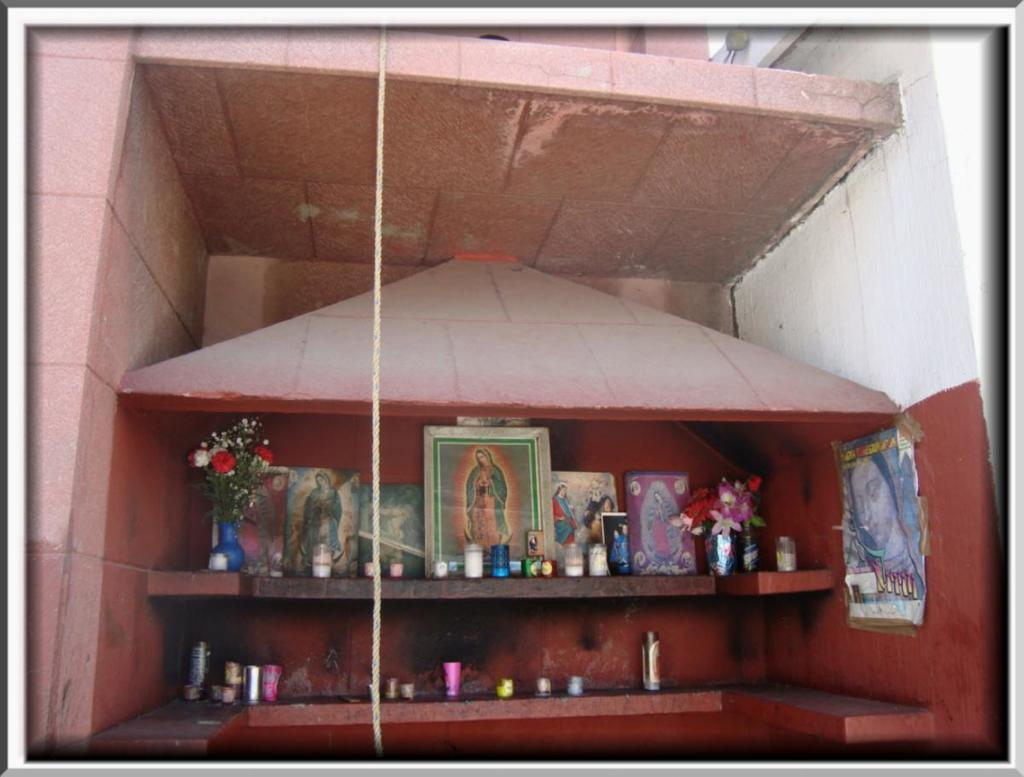What can be seen on the shelf in the image? There is a photo of Jesus and a flower vase on the shelf in the image. Can you describe the photo on the shelf? The photo on the shelf is of Jesus. What else is present on the shelf besides the photo? There is a flower vase on the shelf. How many boys are visible in the image? There are no boys visible in the image; it only features a shelf with a photo of Jesus and a flower vase. What type of cow can be seen grazing in the background of the image? There is no cow present in the image; it only features a shelf with a photo of Jesus and a flower vase. 